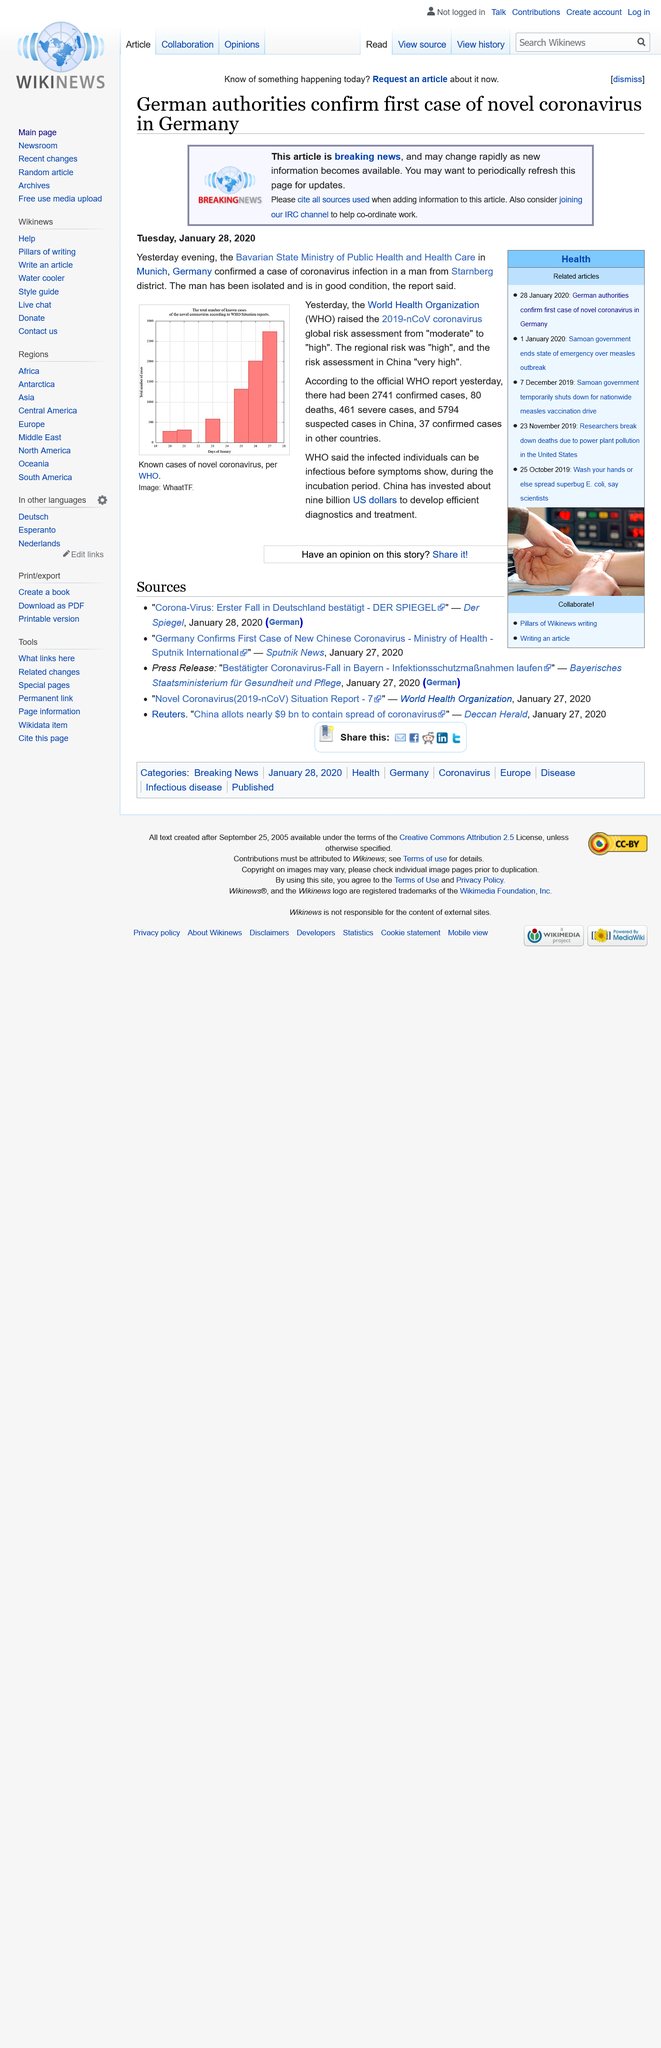Mention a couple of crucial points in this snapshot. As of February 14, there have been a total of 2731 confirmed cases of COVID-19 within China. The abbreviation WHO represents the World Health Organization, a global agency responsible for promoting and protecting public health. The graph illustrates the number of reported cases of the novel Coronavirus, as reported by the World Health Organization (WHO), as of a certain date. 